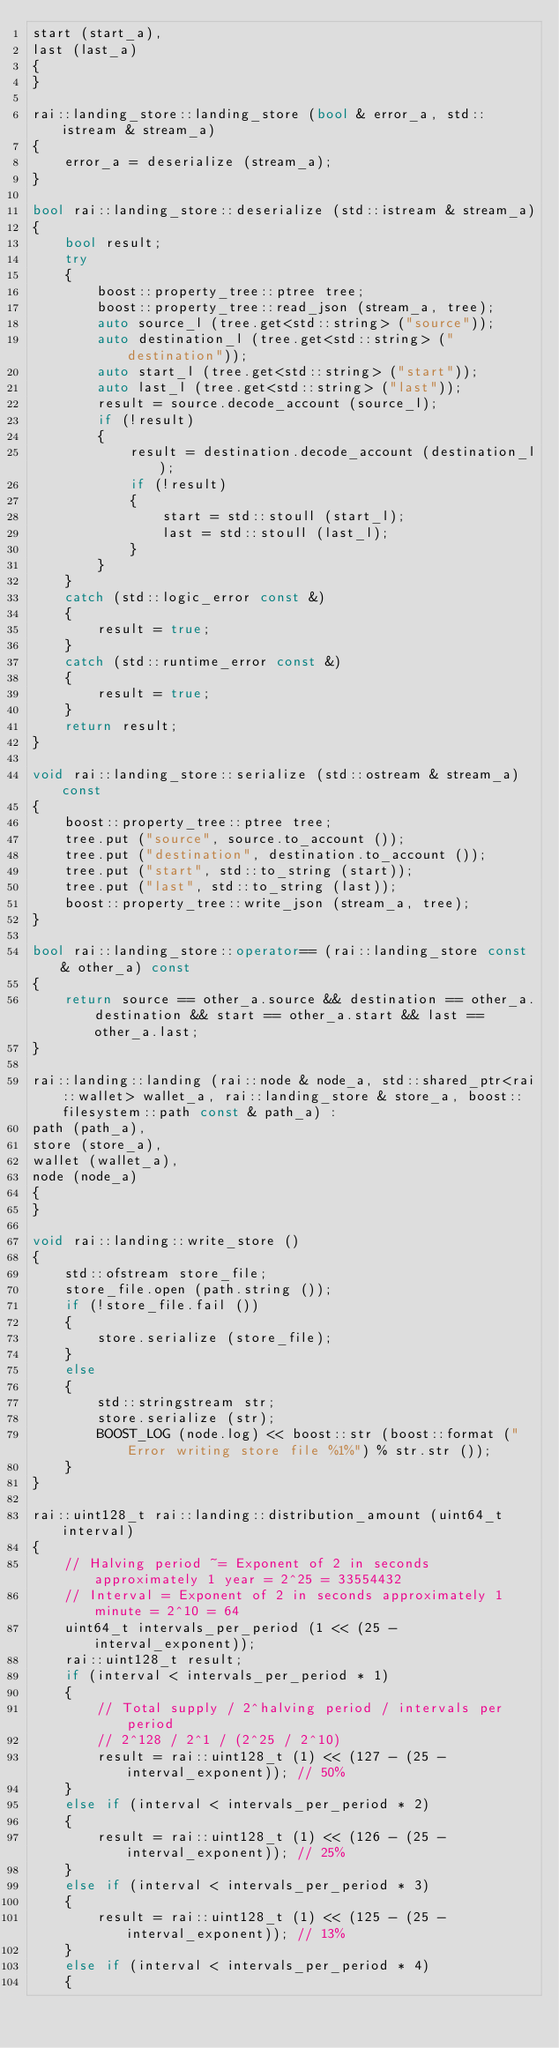<code> <loc_0><loc_0><loc_500><loc_500><_C++_>start (start_a),
last (last_a)
{
}

rai::landing_store::landing_store (bool & error_a, std::istream & stream_a)
{
	error_a = deserialize (stream_a);
}

bool rai::landing_store::deserialize (std::istream & stream_a)
{
	bool result;
	try
	{
		boost::property_tree::ptree tree;
		boost::property_tree::read_json (stream_a, tree);
		auto source_l (tree.get<std::string> ("source"));
		auto destination_l (tree.get<std::string> ("destination"));
		auto start_l (tree.get<std::string> ("start"));
		auto last_l (tree.get<std::string> ("last"));
		result = source.decode_account (source_l);
		if (!result)
		{
			result = destination.decode_account (destination_l);
			if (!result)
			{
				start = std::stoull (start_l);
				last = std::stoull (last_l);
			}
		}
	}
	catch (std::logic_error const &)
	{
		result = true;
	}
	catch (std::runtime_error const &)
	{
		result = true;
	}
	return result;
}

void rai::landing_store::serialize (std::ostream & stream_a) const
{
	boost::property_tree::ptree tree;
	tree.put ("source", source.to_account ());
	tree.put ("destination", destination.to_account ());
	tree.put ("start", std::to_string (start));
	tree.put ("last", std::to_string (last));
	boost::property_tree::write_json (stream_a, tree);
}

bool rai::landing_store::operator== (rai::landing_store const & other_a) const
{
	return source == other_a.source && destination == other_a.destination && start == other_a.start && last == other_a.last;
}

rai::landing::landing (rai::node & node_a, std::shared_ptr<rai::wallet> wallet_a, rai::landing_store & store_a, boost::filesystem::path const & path_a) :
path (path_a),
store (store_a),
wallet (wallet_a),
node (node_a)
{
}

void rai::landing::write_store ()
{
	std::ofstream store_file;
	store_file.open (path.string ());
	if (!store_file.fail ())
	{
		store.serialize (store_file);
	}
	else
	{
		std::stringstream str;
		store.serialize (str);
		BOOST_LOG (node.log) << boost::str (boost::format ("Error writing store file %1%") % str.str ());
	}
}

rai::uint128_t rai::landing::distribution_amount (uint64_t interval)
{
	// Halving period ~= Exponent of 2 in seconds approximately 1 year = 2^25 = 33554432
	// Interval = Exponent of 2 in seconds approximately 1 minute = 2^10 = 64
	uint64_t intervals_per_period (1 << (25 - interval_exponent));
	rai::uint128_t result;
	if (interval < intervals_per_period * 1)
	{
		// Total supply / 2^halving period / intervals per period
		// 2^128 / 2^1 / (2^25 / 2^10)
		result = rai::uint128_t (1) << (127 - (25 - interval_exponent)); // 50%
	}
	else if (interval < intervals_per_period * 2)
	{
		result = rai::uint128_t (1) << (126 - (25 - interval_exponent)); // 25%
	}
	else if (interval < intervals_per_period * 3)
	{
		result = rai::uint128_t (1) << (125 - (25 - interval_exponent)); // 13%
	}
	else if (interval < intervals_per_period * 4)
	{</code> 